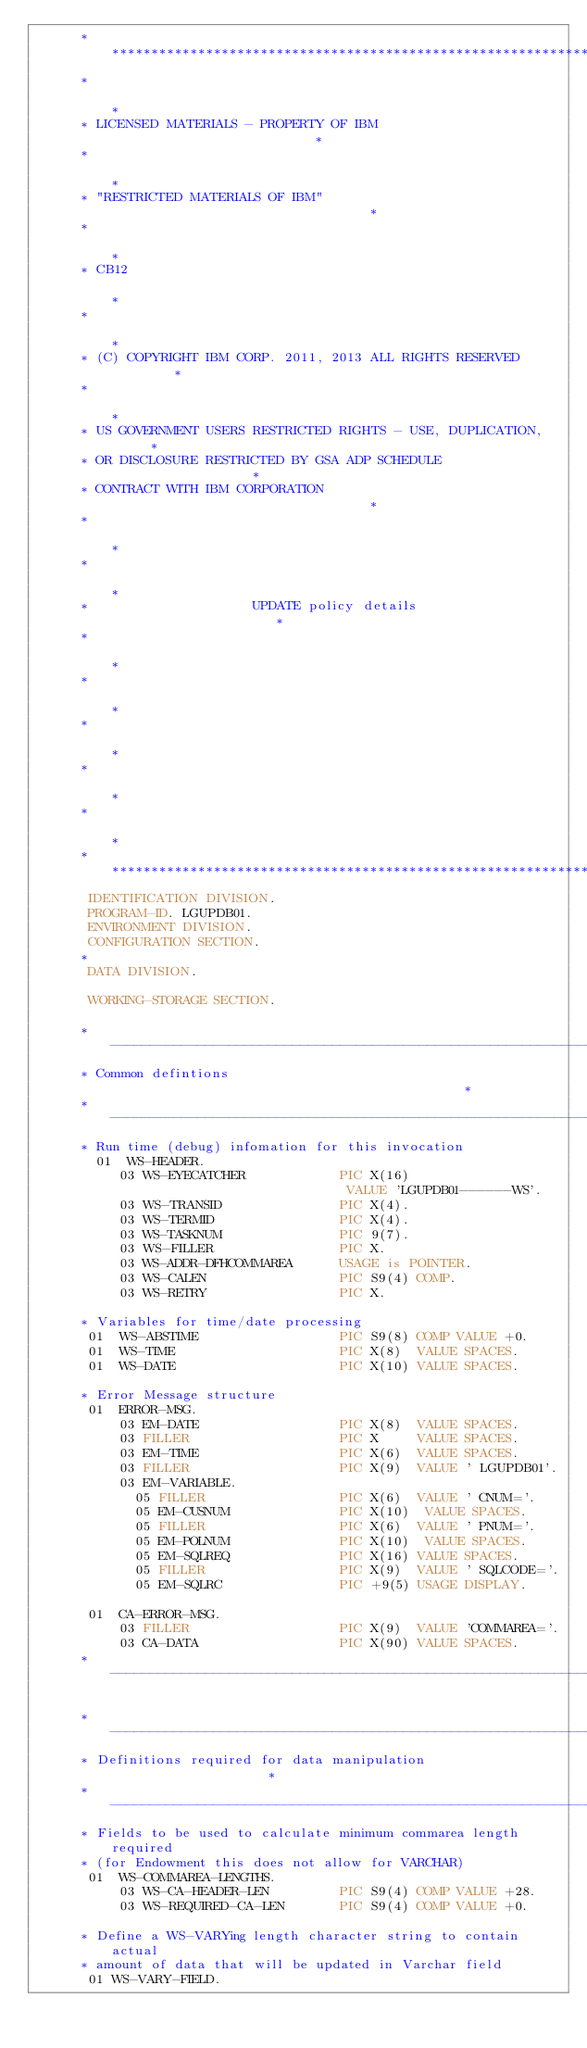Convert code to text. <code><loc_0><loc_0><loc_500><loc_500><_COBOL_>      ******************************************************************
      *                                                                *
      * LICENSED MATERIALS - PROPERTY OF IBM                           *
      *                                                                *
      * "RESTRICTED MATERIALS OF IBM"                                  *
      *                                                                *
      * CB12                                                           *
      *                                                                *
      * (C) COPYRIGHT IBM CORP. 2011, 2013 ALL RIGHTS RESERVED         *
      *                                                                *
      * US GOVERNMENT USERS RESTRICTED RIGHTS - USE, DUPLICATION,      *
      * OR DISCLOSURE RESTRICTED BY GSA ADP SCHEDULE                   *
      * CONTRACT WITH IBM CORPORATION                                  *
      *                                                                *
      *                                                                *
      *                     UPDATE policy details                      *
      *                                                                *
      *                                                                *
      *                                                                *
      *                                                                *
      *                                                                *
      ******************************************************************
       IDENTIFICATION DIVISION.
       PROGRAM-ID. LGUPDB01.
       ENVIRONMENT DIVISION.
       CONFIGURATION SECTION.
      *
       DATA DIVISION.

       WORKING-STORAGE SECTION.

      *----------------------------------------------------------------*
      * Common defintions                                              *
      *----------------------------------------------------------------*
      * Run time (debug) infomation for this invocation
        01  WS-HEADER.
           03 WS-EYECATCHER            PIC X(16)
                                        VALUE 'LGUPDB01------WS'.
           03 WS-TRANSID               PIC X(4).
           03 WS-TERMID                PIC X(4).
           03 WS-TASKNUM               PIC 9(7).
           03 WS-FILLER                PIC X.
           03 WS-ADDR-DFHCOMMAREA      USAGE is POINTER.
           03 WS-CALEN                 PIC S9(4) COMP.
           03 WS-RETRY                 PIC X.

      * Variables for time/date processing
       01  WS-ABSTIME                  PIC S9(8) COMP VALUE +0.
       01  WS-TIME                     PIC X(8)  VALUE SPACES.
       01  WS-DATE                     PIC X(10) VALUE SPACES.

      * Error Message structure
       01  ERROR-MSG.
           03 EM-DATE                  PIC X(8)  VALUE SPACES.
           03 FILLER                   PIC X     VALUE SPACES.
           03 EM-TIME                  PIC X(6)  VALUE SPACES.
           03 FILLER                   PIC X(9)  VALUE ' LGUPDB01'.
           03 EM-VARIABLE.
             05 FILLER                 PIC X(6)  VALUE ' CNUM='.
             05 EM-CUSNUM              PIC X(10)  VALUE SPACES.
             05 FILLER                 PIC X(6)  VALUE ' PNUM='.
             05 EM-POLNUM              PIC X(10)  VALUE SPACES.
             05 EM-SQLREQ              PIC X(16) VALUE SPACES.
             05 FILLER                 PIC X(9)  VALUE ' SQLCODE='.
             05 EM-SQLRC               PIC +9(5) USAGE DISPLAY.

       01  CA-ERROR-MSG.
           03 FILLER                   PIC X(9)  VALUE 'COMMAREA='.
           03 CA-DATA                  PIC X(90) VALUE SPACES.
      *----------------------------------------------------------------*

      *----------------------------------------------------------------*
      * Definitions required for data manipulation                     *
      *----------------------------------------------------------------*
      * Fields to be used to calculate minimum commarea length required
      * (for Endowment this does not allow for VARCHAR)
       01  WS-COMMAREA-LENGTHS.
           03 WS-CA-HEADER-LEN         PIC S9(4) COMP VALUE +28.
           03 WS-REQUIRED-CA-LEN       PIC S9(4) COMP VALUE +0.

      * Define a WS-VARYing length character string to contain actual
      * amount of data that will be updated in Varchar field
       01 WS-VARY-FIELD.</code> 